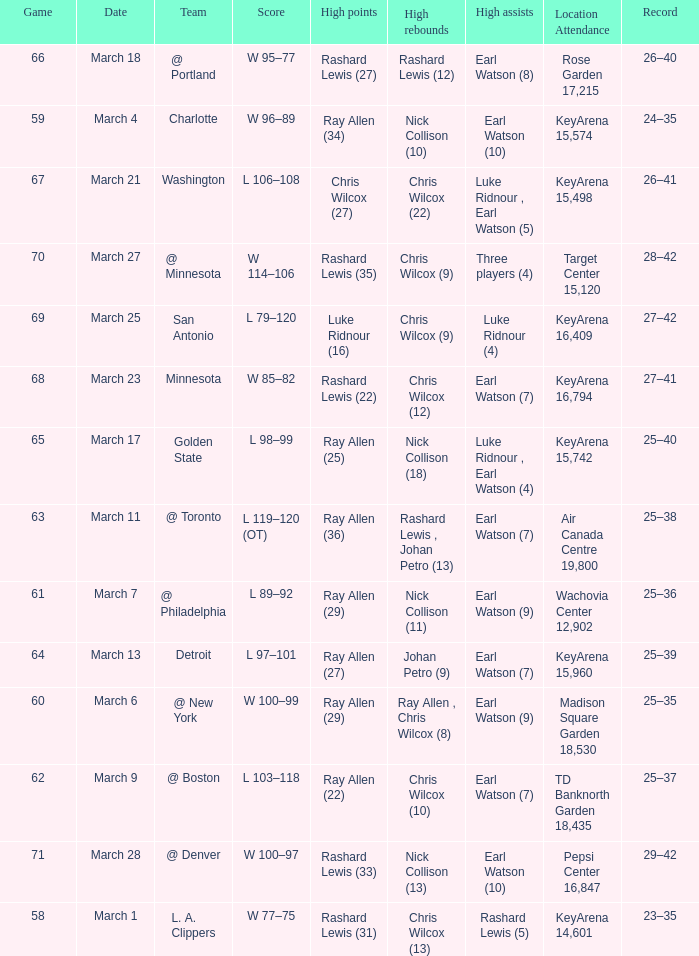Who had the most points in the game on March 7? Ray Allen (29). 